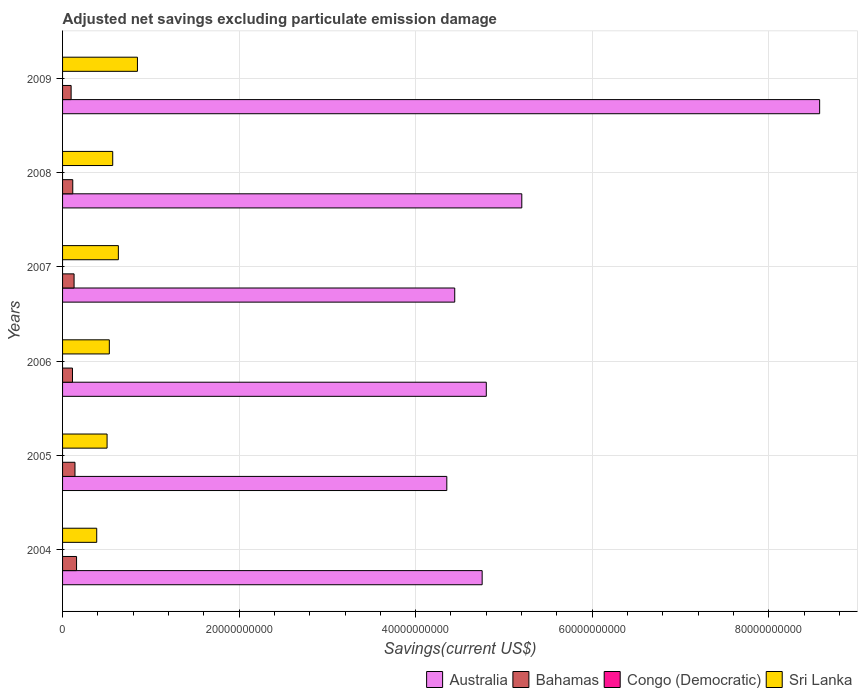Are the number of bars on each tick of the Y-axis equal?
Provide a succinct answer. Yes. How many bars are there on the 3rd tick from the bottom?
Provide a succinct answer. 3. In how many cases, is the number of bars for a given year not equal to the number of legend labels?
Make the answer very short. 6. What is the adjusted net savings in Australia in 2006?
Your answer should be very brief. 4.80e+1. Across all years, what is the maximum adjusted net savings in Bahamas?
Provide a short and direct response. 1.58e+09. In which year was the adjusted net savings in Bahamas maximum?
Provide a short and direct response. 2004. What is the total adjusted net savings in Congo (Democratic) in the graph?
Provide a succinct answer. 0. What is the difference between the adjusted net savings in Sri Lanka in 2007 and that in 2008?
Ensure brevity in your answer.  6.40e+08. What is the difference between the adjusted net savings in Sri Lanka in 2004 and the adjusted net savings in Australia in 2006?
Your answer should be very brief. -4.41e+1. What is the average adjusted net savings in Australia per year?
Keep it short and to the point. 5.35e+1. In the year 2005, what is the difference between the adjusted net savings in Sri Lanka and adjusted net savings in Australia?
Offer a very short reply. -3.85e+1. In how many years, is the adjusted net savings in Bahamas greater than 4000000000 US$?
Offer a very short reply. 0. What is the ratio of the adjusted net savings in Sri Lanka in 2005 to that in 2009?
Your answer should be very brief. 0.59. Is the adjusted net savings in Sri Lanka in 2005 less than that in 2007?
Provide a succinct answer. Yes. What is the difference between the highest and the second highest adjusted net savings in Bahamas?
Make the answer very short. 1.78e+08. What is the difference between the highest and the lowest adjusted net savings in Sri Lanka?
Provide a short and direct response. 4.61e+09. In how many years, is the adjusted net savings in Bahamas greater than the average adjusted net savings in Bahamas taken over all years?
Your response must be concise. 3. Is it the case that in every year, the sum of the adjusted net savings in Bahamas and adjusted net savings in Congo (Democratic) is greater than the adjusted net savings in Sri Lanka?
Offer a terse response. No. Are all the bars in the graph horizontal?
Make the answer very short. Yes. How many years are there in the graph?
Offer a very short reply. 6. What is the difference between two consecutive major ticks on the X-axis?
Offer a very short reply. 2.00e+1. Does the graph contain grids?
Give a very brief answer. Yes. Where does the legend appear in the graph?
Provide a succinct answer. Bottom right. How are the legend labels stacked?
Keep it short and to the point. Horizontal. What is the title of the graph?
Provide a succinct answer. Adjusted net savings excluding particulate emission damage. Does "Caribbean small states" appear as one of the legend labels in the graph?
Make the answer very short. No. What is the label or title of the X-axis?
Provide a succinct answer. Savings(current US$). What is the label or title of the Y-axis?
Make the answer very short. Years. What is the Savings(current US$) of Australia in 2004?
Ensure brevity in your answer.  4.75e+1. What is the Savings(current US$) of Bahamas in 2004?
Provide a short and direct response. 1.58e+09. What is the Savings(current US$) in Sri Lanka in 2004?
Your answer should be compact. 3.87e+09. What is the Savings(current US$) in Australia in 2005?
Your answer should be compact. 4.35e+1. What is the Savings(current US$) of Bahamas in 2005?
Keep it short and to the point. 1.41e+09. What is the Savings(current US$) in Congo (Democratic) in 2005?
Your answer should be compact. 0. What is the Savings(current US$) of Sri Lanka in 2005?
Keep it short and to the point. 5.04e+09. What is the Savings(current US$) of Australia in 2006?
Ensure brevity in your answer.  4.80e+1. What is the Savings(current US$) of Bahamas in 2006?
Offer a very short reply. 1.12e+09. What is the Savings(current US$) in Sri Lanka in 2006?
Provide a short and direct response. 5.30e+09. What is the Savings(current US$) in Australia in 2007?
Offer a very short reply. 4.44e+1. What is the Savings(current US$) of Bahamas in 2007?
Give a very brief answer. 1.30e+09. What is the Savings(current US$) of Congo (Democratic) in 2007?
Your answer should be very brief. 0. What is the Savings(current US$) in Sri Lanka in 2007?
Provide a short and direct response. 6.32e+09. What is the Savings(current US$) in Australia in 2008?
Offer a terse response. 5.20e+1. What is the Savings(current US$) of Bahamas in 2008?
Provide a short and direct response. 1.16e+09. What is the Savings(current US$) of Sri Lanka in 2008?
Give a very brief answer. 5.68e+09. What is the Savings(current US$) of Australia in 2009?
Your response must be concise. 8.58e+1. What is the Savings(current US$) in Bahamas in 2009?
Your answer should be compact. 9.70e+08. What is the Savings(current US$) in Sri Lanka in 2009?
Provide a short and direct response. 8.48e+09. Across all years, what is the maximum Savings(current US$) of Australia?
Keep it short and to the point. 8.58e+1. Across all years, what is the maximum Savings(current US$) in Bahamas?
Your answer should be compact. 1.58e+09. Across all years, what is the maximum Savings(current US$) in Sri Lanka?
Offer a very short reply. 8.48e+09. Across all years, what is the minimum Savings(current US$) in Australia?
Offer a very short reply. 4.35e+1. Across all years, what is the minimum Savings(current US$) in Bahamas?
Offer a very short reply. 9.70e+08. Across all years, what is the minimum Savings(current US$) of Sri Lanka?
Keep it short and to the point. 3.87e+09. What is the total Savings(current US$) in Australia in the graph?
Provide a succinct answer. 3.21e+11. What is the total Savings(current US$) in Bahamas in the graph?
Offer a terse response. 7.55e+09. What is the total Savings(current US$) in Congo (Democratic) in the graph?
Offer a very short reply. 0. What is the total Savings(current US$) of Sri Lanka in the graph?
Make the answer very short. 3.47e+1. What is the difference between the Savings(current US$) of Australia in 2004 and that in 2005?
Give a very brief answer. 4.00e+09. What is the difference between the Savings(current US$) of Bahamas in 2004 and that in 2005?
Offer a very short reply. 1.78e+08. What is the difference between the Savings(current US$) in Sri Lanka in 2004 and that in 2005?
Your response must be concise. -1.17e+09. What is the difference between the Savings(current US$) of Australia in 2004 and that in 2006?
Provide a succinct answer. -4.69e+08. What is the difference between the Savings(current US$) in Bahamas in 2004 and that in 2006?
Your answer should be compact. 4.61e+08. What is the difference between the Savings(current US$) in Sri Lanka in 2004 and that in 2006?
Offer a terse response. -1.43e+09. What is the difference between the Savings(current US$) in Australia in 2004 and that in 2007?
Your answer should be very brief. 3.11e+09. What is the difference between the Savings(current US$) in Bahamas in 2004 and that in 2007?
Provide a succinct answer. 2.80e+08. What is the difference between the Savings(current US$) in Sri Lanka in 2004 and that in 2007?
Offer a terse response. -2.45e+09. What is the difference between the Savings(current US$) of Australia in 2004 and that in 2008?
Keep it short and to the point. -4.49e+09. What is the difference between the Savings(current US$) of Bahamas in 2004 and that in 2008?
Your answer should be very brief. 4.29e+08. What is the difference between the Savings(current US$) of Sri Lanka in 2004 and that in 2008?
Your response must be concise. -1.81e+09. What is the difference between the Savings(current US$) in Australia in 2004 and that in 2009?
Provide a succinct answer. -3.82e+1. What is the difference between the Savings(current US$) of Bahamas in 2004 and that in 2009?
Offer a terse response. 6.14e+08. What is the difference between the Savings(current US$) of Sri Lanka in 2004 and that in 2009?
Your answer should be compact. -4.61e+09. What is the difference between the Savings(current US$) in Australia in 2005 and that in 2006?
Ensure brevity in your answer.  -4.47e+09. What is the difference between the Savings(current US$) of Bahamas in 2005 and that in 2006?
Offer a terse response. 2.83e+08. What is the difference between the Savings(current US$) in Sri Lanka in 2005 and that in 2006?
Offer a very short reply. -2.56e+08. What is the difference between the Savings(current US$) of Australia in 2005 and that in 2007?
Offer a terse response. -8.97e+08. What is the difference between the Savings(current US$) of Bahamas in 2005 and that in 2007?
Offer a terse response. 1.02e+08. What is the difference between the Savings(current US$) of Sri Lanka in 2005 and that in 2007?
Your response must be concise. -1.28e+09. What is the difference between the Savings(current US$) in Australia in 2005 and that in 2008?
Offer a very short reply. -8.49e+09. What is the difference between the Savings(current US$) in Bahamas in 2005 and that in 2008?
Make the answer very short. 2.51e+08. What is the difference between the Savings(current US$) of Sri Lanka in 2005 and that in 2008?
Make the answer very short. -6.40e+08. What is the difference between the Savings(current US$) of Australia in 2005 and that in 2009?
Your answer should be compact. -4.22e+1. What is the difference between the Savings(current US$) of Bahamas in 2005 and that in 2009?
Keep it short and to the point. 4.37e+08. What is the difference between the Savings(current US$) in Sri Lanka in 2005 and that in 2009?
Your response must be concise. -3.44e+09. What is the difference between the Savings(current US$) of Australia in 2006 and that in 2007?
Your answer should be very brief. 3.58e+09. What is the difference between the Savings(current US$) in Bahamas in 2006 and that in 2007?
Your answer should be very brief. -1.81e+08. What is the difference between the Savings(current US$) in Sri Lanka in 2006 and that in 2007?
Your answer should be very brief. -1.02e+09. What is the difference between the Savings(current US$) of Australia in 2006 and that in 2008?
Your answer should be very brief. -4.02e+09. What is the difference between the Savings(current US$) in Bahamas in 2006 and that in 2008?
Provide a succinct answer. -3.17e+07. What is the difference between the Savings(current US$) in Sri Lanka in 2006 and that in 2008?
Your answer should be compact. -3.84e+08. What is the difference between the Savings(current US$) in Australia in 2006 and that in 2009?
Provide a succinct answer. -3.78e+1. What is the difference between the Savings(current US$) in Bahamas in 2006 and that in 2009?
Keep it short and to the point. 1.54e+08. What is the difference between the Savings(current US$) in Sri Lanka in 2006 and that in 2009?
Your response must be concise. -3.18e+09. What is the difference between the Savings(current US$) in Australia in 2007 and that in 2008?
Keep it short and to the point. -7.60e+09. What is the difference between the Savings(current US$) in Bahamas in 2007 and that in 2008?
Provide a succinct answer. 1.49e+08. What is the difference between the Savings(current US$) of Sri Lanka in 2007 and that in 2008?
Provide a succinct answer. 6.40e+08. What is the difference between the Savings(current US$) of Australia in 2007 and that in 2009?
Offer a very short reply. -4.13e+1. What is the difference between the Savings(current US$) of Bahamas in 2007 and that in 2009?
Ensure brevity in your answer.  3.35e+08. What is the difference between the Savings(current US$) in Sri Lanka in 2007 and that in 2009?
Your answer should be very brief. -2.16e+09. What is the difference between the Savings(current US$) of Australia in 2008 and that in 2009?
Your answer should be compact. -3.37e+1. What is the difference between the Savings(current US$) of Bahamas in 2008 and that in 2009?
Your response must be concise. 1.85e+08. What is the difference between the Savings(current US$) in Sri Lanka in 2008 and that in 2009?
Ensure brevity in your answer.  -2.80e+09. What is the difference between the Savings(current US$) in Australia in 2004 and the Savings(current US$) in Bahamas in 2005?
Offer a terse response. 4.61e+1. What is the difference between the Savings(current US$) of Australia in 2004 and the Savings(current US$) of Sri Lanka in 2005?
Provide a succinct answer. 4.25e+1. What is the difference between the Savings(current US$) in Bahamas in 2004 and the Savings(current US$) in Sri Lanka in 2005?
Make the answer very short. -3.46e+09. What is the difference between the Savings(current US$) in Australia in 2004 and the Savings(current US$) in Bahamas in 2006?
Offer a terse response. 4.64e+1. What is the difference between the Savings(current US$) in Australia in 2004 and the Savings(current US$) in Sri Lanka in 2006?
Offer a terse response. 4.22e+1. What is the difference between the Savings(current US$) in Bahamas in 2004 and the Savings(current US$) in Sri Lanka in 2006?
Keep it short and to the point. -3.71e+09. What is the difference between the Savings(current US$) of Australia in 2004 and the Savings(current US$) of Bahamas in 2007?
Ensure brevity in your answer.  4.62e+1. What is the difference between the Savings(current US$) of Australia in 2004 and the Savings(current US$) of Sri Lanka in 2007?
Offer a terse response. 4.12e+1. What is the difference between the Savings(current US$) in Bahamas in 2004 and the Savings(current US$) in Sri Lanka in 2007?
Your answer should be very brief. -4.74e+09. What is the difference between the Savings(current US$) of Australia in 2004 and the Savings(current US$) of Bahamas in 2008?
Your answer should be very brief. 4.64e+1. What is the difference between the Savings(current US$) in Australia in 2004 and the Savings(current US$) in Sri Lanka in 2008?
Your response must be concise. 4.18e+1. What is the difference between the Savings(current US$) in Bahamas in 2004 and the Savings(current US$) in Sri Lanka in 2008?
Your response must be concise. -4.10e+09. What is the difference between the Savings(current US$) in Australia in 2004 and the Savings(current US$) in Bahamas in 2009?
Provide a short and direct response. 4.66e+1. What is the difference between the Savings(current US$) in Australia in 2004 and the Savings(current US$) in Sri Lanka in 2009?
Provide a short and direct response. 3.90e+1. What is the difference between the Savings(current US$) of Bahamas in 2004 and the Savings(current US$) of Sri Lanka in 2009?
Keep it short and to the point. -6.90e+09. What is the difference between the Savings(current US$) in Australia in 2005 and the Savings(current US$) in Bahamas in 2006?
Ensure brevity in your answer.  4.24e+1. What is the difference between the Savings(current US$) in Australia in 2005 and the Savings(current US$) in Sri Lanka in 2006?
Provide a succinct answer. 3.82e+1. What is the difference between the Savings(current US$) in Bahamas in 2005 and the Savings(current US$) in Sri Lanka in 2006?
Offer a very short reply. -3.89e+09. What is the difference between the Savings(current US$) in Australia in 2005 and the Savings(current US$) in Bahamas in 2007?
Provide a short and direct response. 4.22e+1. What is the difference between the Savings(current US$) of Australia in 2005 and the Savings(current US$) of Sri Lanka in 2007?
Keep it short and to the point. 3.72e+1. What is the difference between the Savings(current US$) in Bahamas in 2005 and the Savings(current US$) in Sri Lanka in 2007?
Provide a short and direct response. -4.91e+09. What is the difference between the Savings(current US$) in Australia in 2005 and the Savings(current US$) in Bahamas in 2008?
Your response must be concise. 4.24e+1. What is the difference between the Savings(current US$) of Australia in 2005 and the Savings(current US$) of Sri Lanka in 2008?
Give a very brief answer. 3.78e+1. What is the difference between the Savings(current US$) in Bahamas in 2005 and the Savings(current US$) in Sri Lanka in 2008?
Keep it short and to the point. -4.27e+09. What is the difference between the Savings(current US$) in Australia in 2005 and the Savings(current US$) in Bahamas in 2009?
Give a very brief answer. 4.26e+1. What is the difference between the Savings(current US$) in Australia in 2005 and the Savings(current US$) in Sri Lanka in 2009?
Your answer should be compact. 3.50e+1. What is the difference between the Savings(current US$) of Bahamas in 2005 and the Savings(current US$) of Sri Lanka in 2009?
Offer a terse response. -7.08e+09. What is the difference between the Savings(current US$) in Australia in 2006 and the Savings(current US$) in Bahamas in 2007?
Offer a very short reply. 4.67e+1. What is the difference between the Savings(current US$) in Australia in 2006 and the Savings(current US$) in Sri Lanka in 2007?
Your response must be concise. 4.17e+1. What is the difference between the Savings(current US$) in Bahamas in 2006 and the Savings(current US$) in Sri Lanka in 2007?
Make the answer very short. -5.20e+09. What is the difference between the Savings(current US$) of Australia in 2006 and the Savings(current US$) of Bahamas in 2008?
Your response must be concise. 4.68e+1. What is the difference between the Savings(current US$) in Australia in 2006 and the Savings(current US$) in Sri Lanka in 2008?
Offer a terse response. 4.23e+1. What is the difference between the Savings(current US$) in Bahamas in 2006 and the Savings(current US$) in Sri Lanka in 2008?
Your answer should be very brief. -4.56e+09. What is the difference between the Savings(current US$) of Australia in 2006 and the Savings(current US$) of Bahamas in 2009?
Provide a succinct answer. 4.70e+1. What is the difference between the Savings(current US$) in Australia in 2006 and the Savings(current US$) in Sri Lanka in 2009?
Your answer should be compact. 3.95e+1. What is the difference between the Savings(current US$) in Bahamas in 2006 and the Savings(current US$) in Sri Lanka in 2009?
Make the answer very short. -7.36e+09. What is the difference between the Savings(current US$) in Australia in 2007 and the Savings(current US$) in Bahamas in 2008?
Your response must be concise. 4.33e+1. What is the difference between the Savings(current US$) of Australia in 2007 and the Savings(current US$) of Sri Lanka in 2008?
Make the answer very short. 3.87e+1. What is the difference between the Savings(current US$) in Bahamas in 2007 and the Savings(current US$) in Sri Lanka in 2008?
Ensure brevity in your answer.  -4.38e+09. What is the difference between the Savings(current US$) in Australia in 2007 and the Savings(current US$) in Bahamas in 2009?
Offer a terse response. 4.35e+1. What is the difference between the Savings(current US$) in Australia in 2007 and the Savings(current US$) in Sri Lanka in 2009?
Your response must be concise. 3.59e+1. What is the difference between the Savings(current US$) of Bahamas in 2007 and the Savings(current US$) of Sri Lanka in 2009?
Make the answer very short. -7.18e+09. What is the difference between the Savings(current US$) in Australia in 2008 and the Savings(current US$) in Bahamas in 2009?
Your answer should be very brief. 5.11e+1. What is the difference between the Savings(current US$) in Australia in 2008 and the Savings(current US$) in Sri Lanka in 2009?
Offer a terse response. 4.35e+1. What is the difference between the Savings(current US$) in Bahamas in 2008 and the Savings(current US$) in Sri Lanka in 2009?
Offer a very short reply. -7.33e+09. What is the average Savings(current US$) in Australia per year?
Your answer should be very brief. 5.35e+1. What is the average Savings(current US$) of Bahamas per year?
Give a very brief answer. 1.26e+09. What is the average Savings(current US$) of Congo (Democratic) per year?
Make the answer very short. 0. What is the average Savings(current US$) in Sri Lanka per year?
Provide a succinct answer. 5.78e+09. In the year 2004, what is the difference between the Savings(current US$) in Australia and Savings(current US$) in Bahamas?
Keep it short and to the point. 4.59e+1. In the year 2004, what is the difference between the Savings(current US$) in Australia and Savings(current US$) in Sri Lanka?
Ensure brevity in your answer.  4.37e+1. In the year 2004, what is the difference between the Savings(current US$) of Bahamas and Savings(current US$) of Sri Lanka?
Ensure brevity in your answer.  -2.28e+09. In the year 2005, what is the difference between the Savings(current US$) in Australia and Savings(current US$) in Bahamas?
Give a very brief answer. 4.21e+1. In the year 2005, what is the difference between the Savings(current US$) in Australia and Savings(current US$) in Sri Lanka?
Provide a short and direct response. 3.85e+1. In the year 2005, what is the difference between the Savings(current US$) of Bahamas and Savings(current US$) of Sri Lanka?
Offer a terse response. -3.64e+09. In the year 2006, what is the difference between the Savings(current US$) in Australia and Savings(current US$) in Bahamas?
Your response must be concise. 4.69e+1. In the year 2006, what is the difference between the Savings(current US$) of Australia and Savings(current US$) of Sri Lanka?
Keep it short and to the point. 4.27e+1. In the year 2006, what is the difference between the Savings(current US$) in Bahamas and Savings(current US$) in Sri Lanka?
Keep it short and to the point. -4.17e+09. In the year 2007, what is the difference between the Savings(current US$) of Australia and Savings(current US$) of Bahamas?
Your answer should be very brief. 4.31e+1. In the year 2007, what is the difference between the Savings(current US$) in Australia and Savings(current US$) in Sri Lanka?
Your answer should be compact. 3.81e+1. In the year 2007, what is the difference between the Savings(current US$) of Bahamas and Savings(current US$) of Sri Lanka?
Offer a terse response. -5.02e+09. In the year 2008, what is the difference between the Savings(current US$) of Australia and Savings(current US$) of Bahamas?
Your response must be concise. 5.09e+1. In the year 2008, what is the difference between the Savings(current US$) in Australia and Savings(current US$) in Sri Lanka?
Provide a succinct answer. 4.63e+1. In the year 2008, what is the difference between the Savings(current US$) of Bahamas and Savings(current US$) of Sri Lanka?
Your answer should be very brief. -4.53e+09. In the year 2009, what is the difference between the Savings(current US$) of Australia and Savings(current US$) of Bahamas?
Offer a terse response. 8.48e+1. In the year 2009, what is the difference between the Savings(current US$) in Australia and Savings(current US$) in Sri Lanka?
Keep it short and to the point. 7.73e+1. In the year 2009, what is the difference between the Savings(current US$) in Bahamas and Savings(current US$) in Sri Lanka?
Your response must be concise. -7.51e+09. What is the ratio of the Savings(current US$) of Australia in 2004 to that in 2005?
Your answer should be very brief. 1.09. What is the ratio of the Savings(current US$) of Bahamas in 2004 to that in 2005?
Ensure brevity in your answer.  1.13. What is the ratio of the Savings(current US$) in Sri Lanka in 2004 to that in 2005?
Your answer should be very brief. 0.77. What is the ratio of the Savings(current US$) in Australia in 2004 to that in 2006?
Your response must be concise. 0.99. What is the ratio of the Savings(current US$) of Bahamas in 2004 to that in 2006?
Provide a succinct answer. 1.41. What is the ratio of the Savings(current US$) of Sri Lanka in 2004 to that in 2006?
Ensure brevity in your answer.  0.73. What is the ratio of the Savings(current US$) of Australia in 2004 to that in 2007?
Offer a terse response. 1.07. What is the ratio of the Savings(current US$) of Bahamas in 2004 to that in 2007?
Your answer should be very brief. 1.21. What is the ratio of the Savings(current US$) of Sri Lanka in 2004 to that in 2007?
Keep it short and to the point. 0.61. What is the ratio of the Savings(current US$) of Australia in 2004 to that in 2008?
Give a very brief answer. 0.91. What is the ratio of the Savings(current US$) of Bahamas in 2004 to that in 2008?
Offer a very short reply. 1.37. What is the ratio of the Savings(current US$) of Sri Lanka in 2004 to that in 2008?
Make the answer very short. 0.68. What is the ratio of the Savings(current US$) in Australia in 2004 to that in 2009?
Make the answer very short. 0.55. What is the ratio of the Savings(current US$) of Bahamas in 2004 to that in 2009?
Your answer should be compact. 1.63. What is the ratio of the Savings(current US$) in Sri Lanka in 2004 to that in 2009?
Give a very brief answer. 0.46. What is the ratio of the Savings(current US$) of Australia in 2005 to that in 2006?
Make the answer very short. 0.91. What is the ratio of the Savings(current US$) in Bahamas in 2005 to that in 2006?
Make the answer very short. 1.25. What is the ratio of the Savings(current US$) of Sri Lanka in 2005 to that in 2006?
Your answer should be compact. 0.95. What is the ratio of the Savings(current US$) of Australia in 2005 to that in 2007?
Give a very brief answer. 0.98. What is the ratio of the Savings(current US$) of Bahamas in 2005 to that in 2007?
Your answer should be very brief. 1.08. What is the ratio of the Savings(current US$) of Sri Lanka in 2005 to that in 2007?
Provide a succinct answer. 0.8. What is the ratio of the Savings(current US$) of Australia in 2005 to that in 2008?
Provide a short and direct response. 0.84. What is the ratio of the Savings(current US$) in Bahamas in 2005 to that in 2008?
Offer a very short reply. 1.22. What is the ratio of the Savings(current US$) of Sri Lanka in 2005 to that in 2008?
Give a very brief answer. 0.89. What is the ratio of the Savings(current US$) in Australia in 2005 to that in 2009?
Your answer should be very brief. 0.51. What is the ratio of the Savings(current US$) of Bahamas in 2005 to that in 2009?
Keep it short and to the point. 1.45. What is the ratio of the Savings(current US$) of Sri Lanka in 2005 to that in 2009?
Give a very brief answer. 0.59. What is the ratio of the Savings(current US$) of Australia in 2006 to that in 2007?
Ensure brevity in your answer.  1.08. What is the ratio of the Savings(current US$) in Bahamas in 2006 to that in 2007?
Provide a succinct answer. 0.86. What is the ratio of the Savings(current US$) in Sri Lanka in 2006 to that in 2007?
Ensure brevity in your answer.  0.84. What is the ratio of the Savings(current US$) in Australia in 2006 to that in 2008?
Keep it short and to the point. 0.92. What is the ratio of the Savings(current US$) of Bahamas in 2006 to that in 2008?
Ensure brevity in your answer.  0.97. What is the ratio of the Savings(current US$) in Sri Lanka in 2006 to that in 2008?
Your answer should be compact. 0.93. What is the ratio of the Savings(current US$) in Australia in 2006 to that in 2009?
Keep it short and to the point. 0.56. What is the ratio of the Savings(current US$) of Bahamas in 2006 to that in 2009?
Keep it short and to the point. 1.16. What is the ratio of the Savings(current US$) in Sri Lanka in 2006 to that in 2009?
Your answer should be compact. 0.62. What is the ratio of the Savings(current US$) in Australia in 2007 to that in 2008?
Give a very brief answer. 0.85. What is the ratio of the Savings(current US$) of Bahamas in 2007 to that in 2008?
Give a very brief answer. 1.13. What is the ratio of the Savings(current US$) of Sri Lanka in 2007 to that in 2008?
Make the answer very short. 1.11. What is the ratio of the Savings(current US$) in Australia in 2007 to that in 2009?
Offer a very short reply. 0.52. What is the ratio of the Savings(current US$) in Bahamas in 2007 to that in 2009?
Offer a very short reply. 1.34. What is the ratio of the Savings(current US$) in Sri Lanka in 2007 to that in 2009?
Ensure brevity in your answer.  0.75. What is the ratio of the Savings(current US$) in Australia in 2008 to that in 2009?
Your response must be concise. 0.61. What is the ratio of the Savings(current US$) in Bahamas in 2008 to that in 2009?
Provide a succinct answer. 1.19. What is the ratio of the Savings(current US$) in Sri Lanka in 2008 to that in 2009?
Ensure brevity in your answer.  0.67. What is the difference between the highest and the second highest Savings(current US$) in Australia?
Make the answer very short. 3.37e+1. What is the difference between the highest and the second highest Savings(current US$) in Bahamas?
Provide a succinct answer. 1.78e+08. What is the difference between the highest and the second highest Savings(current US$) of Sri Lanka?
Offer a very short reply. 2.16e+09. What is the difference between the highest and the lowest Savings(current US$) in Australia?
Your answer should be very brief. 4.22e+1. What is the difference between the highest and the lowest Savings(current US$) in Bahamas?
Make the answer very short. 6.14e+08. What is the difference between the highest and the lowest Savings(current US$) in Sri Lanka?
Keep it short and to the point. 4.61e+09. 